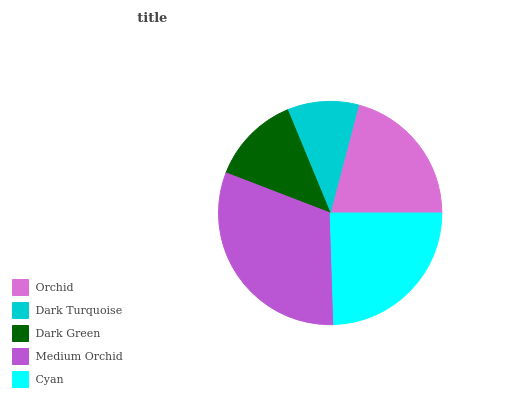Is Dark Turquoise the minimum?
Answer yes or no. Yes. Is Medium Orchid the maximum?
Answer yes or no. Yes. Is Dark Green the minimum?
Answer yes or no. No. Is Dark Green the maximum?
Answer yes or no. No. Is Dark Green greater than Dark Turquoise?
Answer yes or no. Yes. Is Dark Turquoise less than Dark Green?
Answer yes or no. Yes. Is Dark Turquoise greater than Dark Green?
Answer yes or no. No. Is Dark Green less than Dark Turquoise?
Answer yes or no. No. Is Orchid the high median?
Answer yes or no. Yes. Is Orchid the low median?
Answer yes or no. Yes. Is Medium Orchid the high median?
Answer yes or no. No. Is Dark Turquoise the low median?
Answer yes or no. No. 